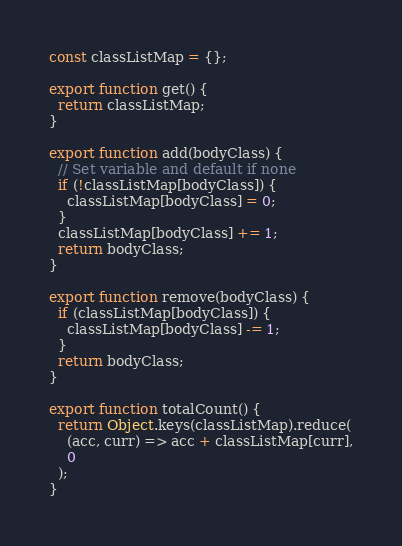Convert code to text. <code><loc_0><loc_0><loc_500><loc_500><_JavaScript_>const classListMap = {};

export function get() {
  return classListMap;
}

export function add(bodyClass) {
  // Set variable and default if none
  if (!classListMap[bodyClass]) {
    classListMap[bodyClass] = 0;
  }
  classListMap[bodyClass] += 1;
  return bodyClass;
}

export function remove(bodyClass) {
  if (classListMap[bodyClass]) {
    classListMap[bodyClass] -= 1;
  }
  return bodyClass;
}

export function totalCount() {
  return Object.keys(classListMap).reduce(
    (acc, curr) => acc + classListMap[curr],
    0
  );
}
</code> 